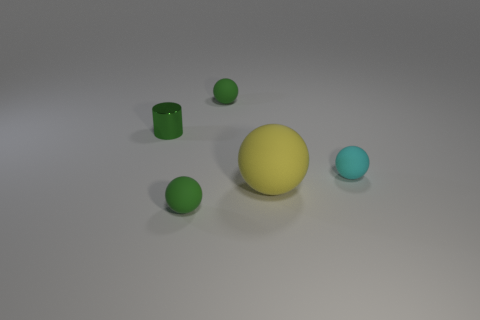Is there anything else that is the same material as the green cylinder?
Your response must be concise. No. Is there any other thing that has the same size as the yellow ball?
Your answer should be compact. No. There is a small thing that is in front of the cyan matte sphere; is its color the same as the small cylinder?
Offer a very short reply. Yes. What number of other objects are there of the same color as the small metallic thing?
Offer a very short reply. 2. Is the large yellow ball made of the same material as the green cylinder?
Your response must be concise. No. What number of other things are there of the same material as the tiny cylinder
Offer a very short reply. 0. Are there more large yellow things than big gray metal cylinders?
Your answer should be very brief. Yes. Is the shape of the tiny green rubber thing that is behind the big rubber sphere the same as  the small green metallic object?
Offer a very short reply. No. Are there fewer metal things than small blue balls?
Provide a succinct answer. No. What is the material of the cylinder that is the same size as the cyan matte ball?
Provide a succinct answer. Metal. 